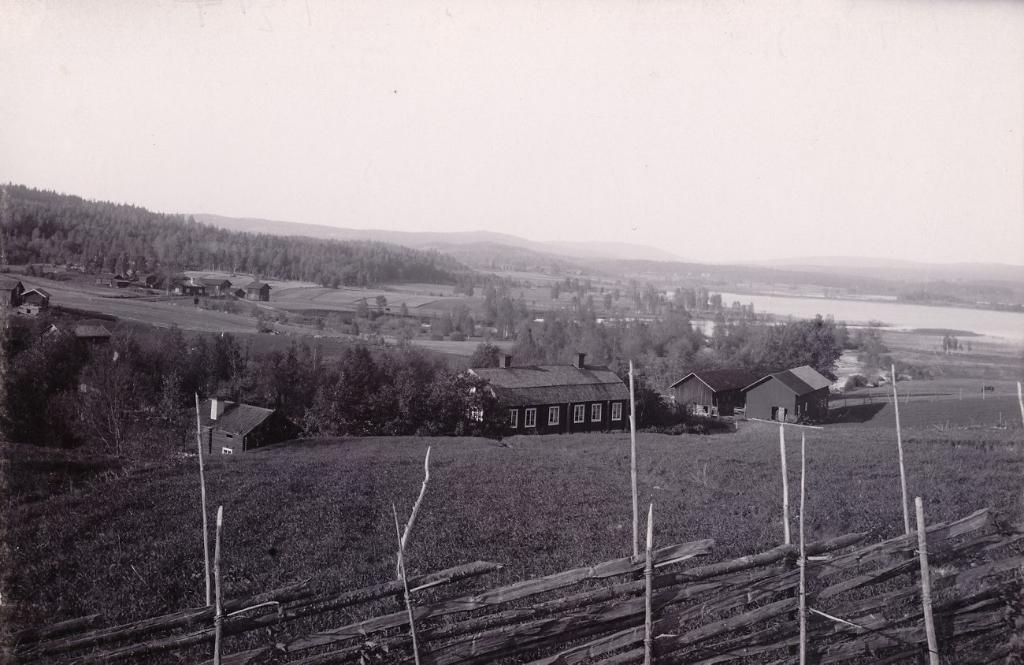Describe this image in one or two sentences. In this image we can see trees, houses, hills and in the background we can see the sky. 